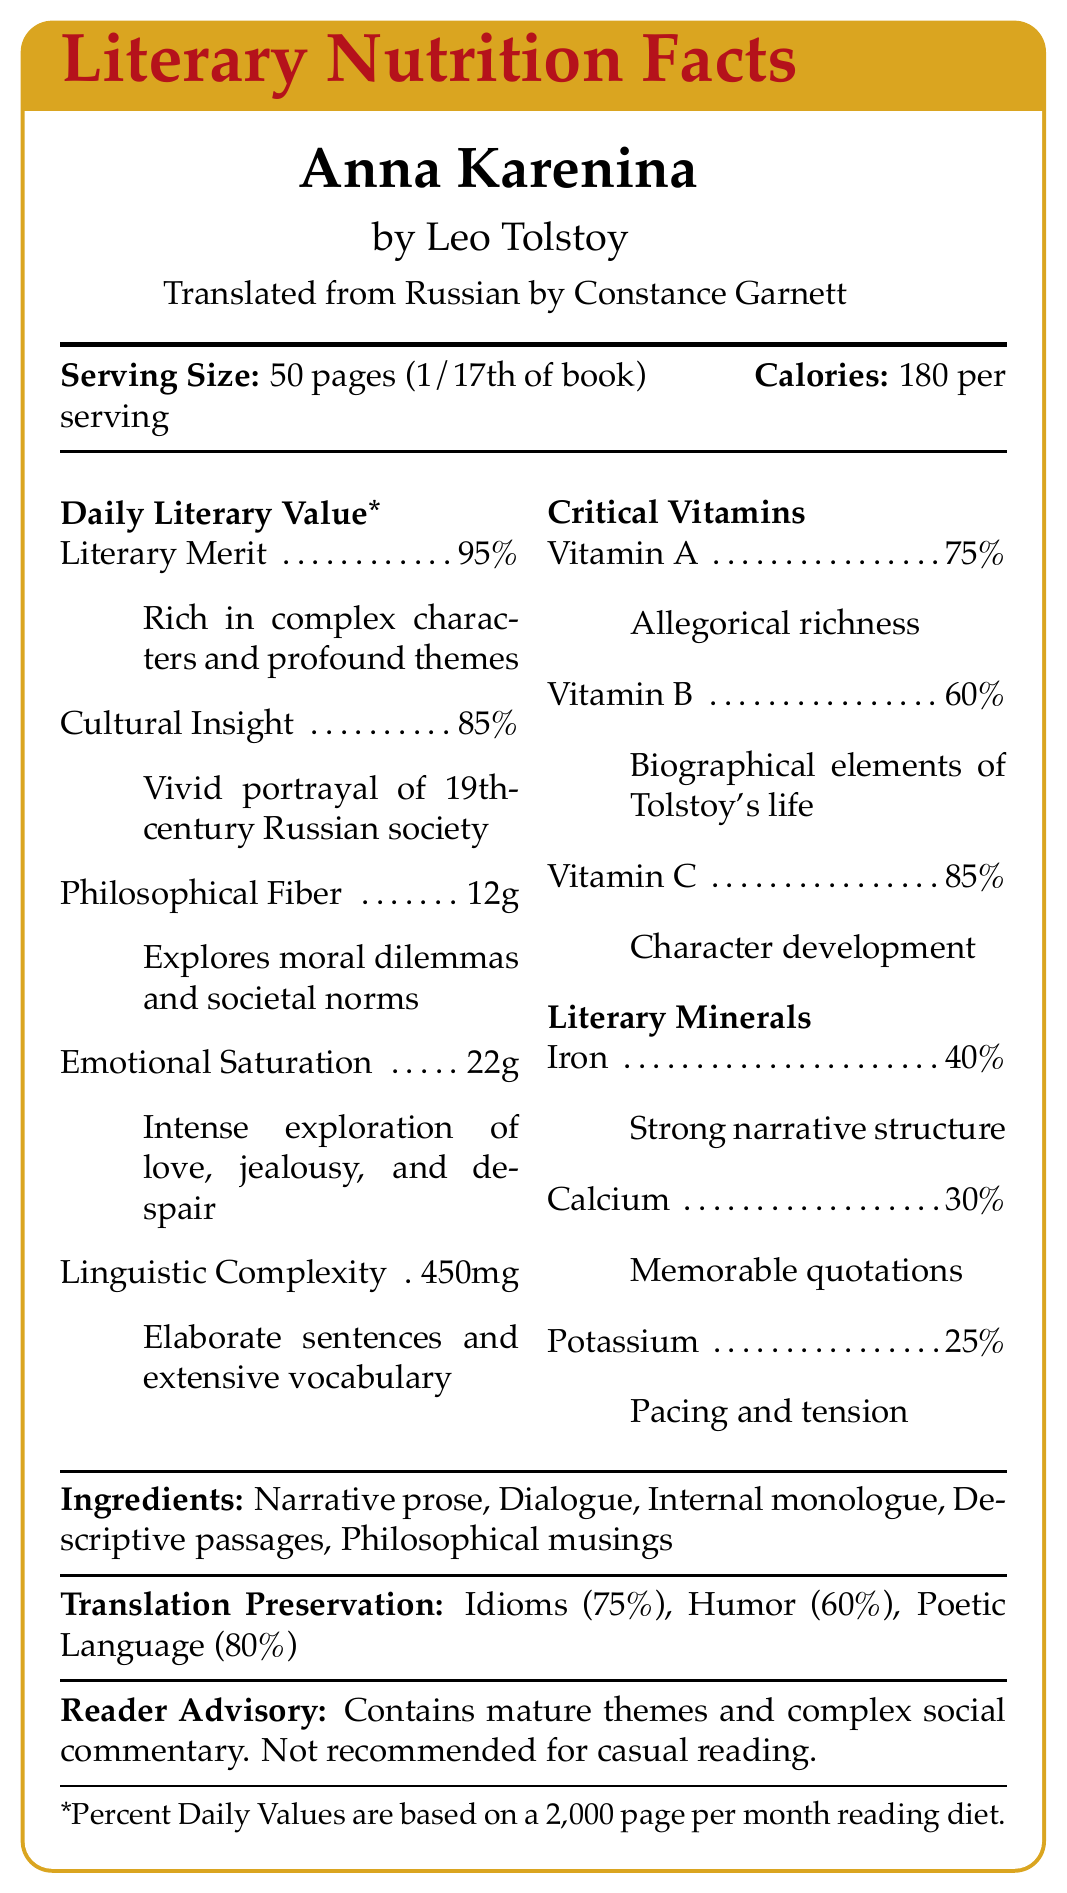- What is the serving size for the novel "Anna Karenina"? The document states that the serving size is 50 pages, which is 1/17th of the book.
Answer: 50 pages - Who translated "Anna Karenina" from Russian to English? The document specifies that the translation from Russian to English was done by Constance Garnett.
Answer: Constance Garnett - How many calories are in one serving of "Anna Karenina"? The document notes that each serving of 50 pages contains 180 calories.
Answer: 180 per serving - What is the percentage of daily value of literary merit in "Anna Karenina"? The nutritional analysis shows that the literary merit of "Anna Karenina" is 95%, indicating its rich, complex characters and profound themes.
Answer: 95% - How many servings are in the novel "Anna Karenina"? The nutritional information details that there are 17 servings in the book.
Answer: 17 servings - Which element is described as having an "intense exploration of love, jealousy, and despair"? A. Literary Merit B. Emotional Saturation C. Cultural Insight D. Philosophical Fiber Emotional Saturation is described as having an intense exploration of love, jealousy, and despair.
Answer: B - What is the authenticity percentage of the translation done by Constance Garnett? A. 80% B. 85% C. 90% The document states that the authenticity of the translation is 90%.
Answer: C - Are there any mature themes in "Anna Karenina"? The reader advisory section indicates that the book contains mature themes and complex social commentary.
Answer: Yes - Can this document tell us the publication year of the English translation? The document does not provide any details about the publication year of the English translation.
Answer: Not enough information - Describe the main idea or purpose of the document. The document offers a nutritional facts-style breakdown of the literary elements and the translation's quality in "Anna Karenina".
Answer: The document provides a detailed literary nutritional analysis of the novel "Anna Karenina" by Leo Tolstoy, as translated by Constance Garnett. It presents the serving size, number of servings, and calorie content per serving. It also breaks down various literary values like literary merit, cultural insight, philosophical fiber, emotional saturation, and linguistic complexity, as well as critical vitamins such as allegorical richness and biographical elements. Additionally, it highlights the ingredients of the novel, gives notes on the translation's authenticity, readability, and cultural nuance retention, and provides a reader advisory. - What is the amount of linguistic complexity in "Anna Karenina"? The nutritional analysis lists linguistic complexity as 450mg.
Answer: 450mg - What percentage of Vitamin A, representing allegorical richness, is present in "Anna Karenina"? The document mentions that Vitamin A (allegorical richness) is present at 75%.
Answer: 75% - How much philosophical fiber does one serving of "Anna Karenina" provide? The document outlines that one serving contains 12g of philosophical fiber.
Answer: 12g - What is the primary ingredient of "Anna Karenina"? A. Dialogue B. Narrative Prose C. Philosophical Musings The main listed ingredient in the document is narrative prose.
Answer: B - What percentage of calcium, representing memorable quotations, is included in the novel? The nutritional analysis states that calcium, which represents memorable quotations, is at 30%.
Answer: 30% 